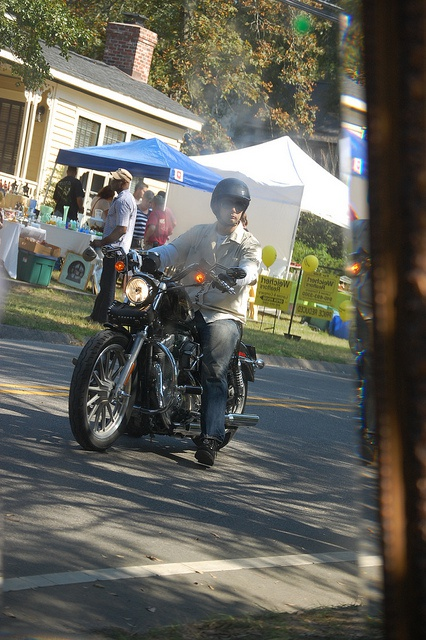Describe the objects in this image and their specific colors. I can see motorcycle in darkgreen, black, gray, darkgray, and darkblue tones, people in darkgreen, gray, black, darkgray, and white tones, people in darkgreen, black, gray, lightgray, and darkgray tones, people in darkgreen, gray, brown, darkgray, and maroon tones, and people in darkgreen, black, and gray tones in this image. 